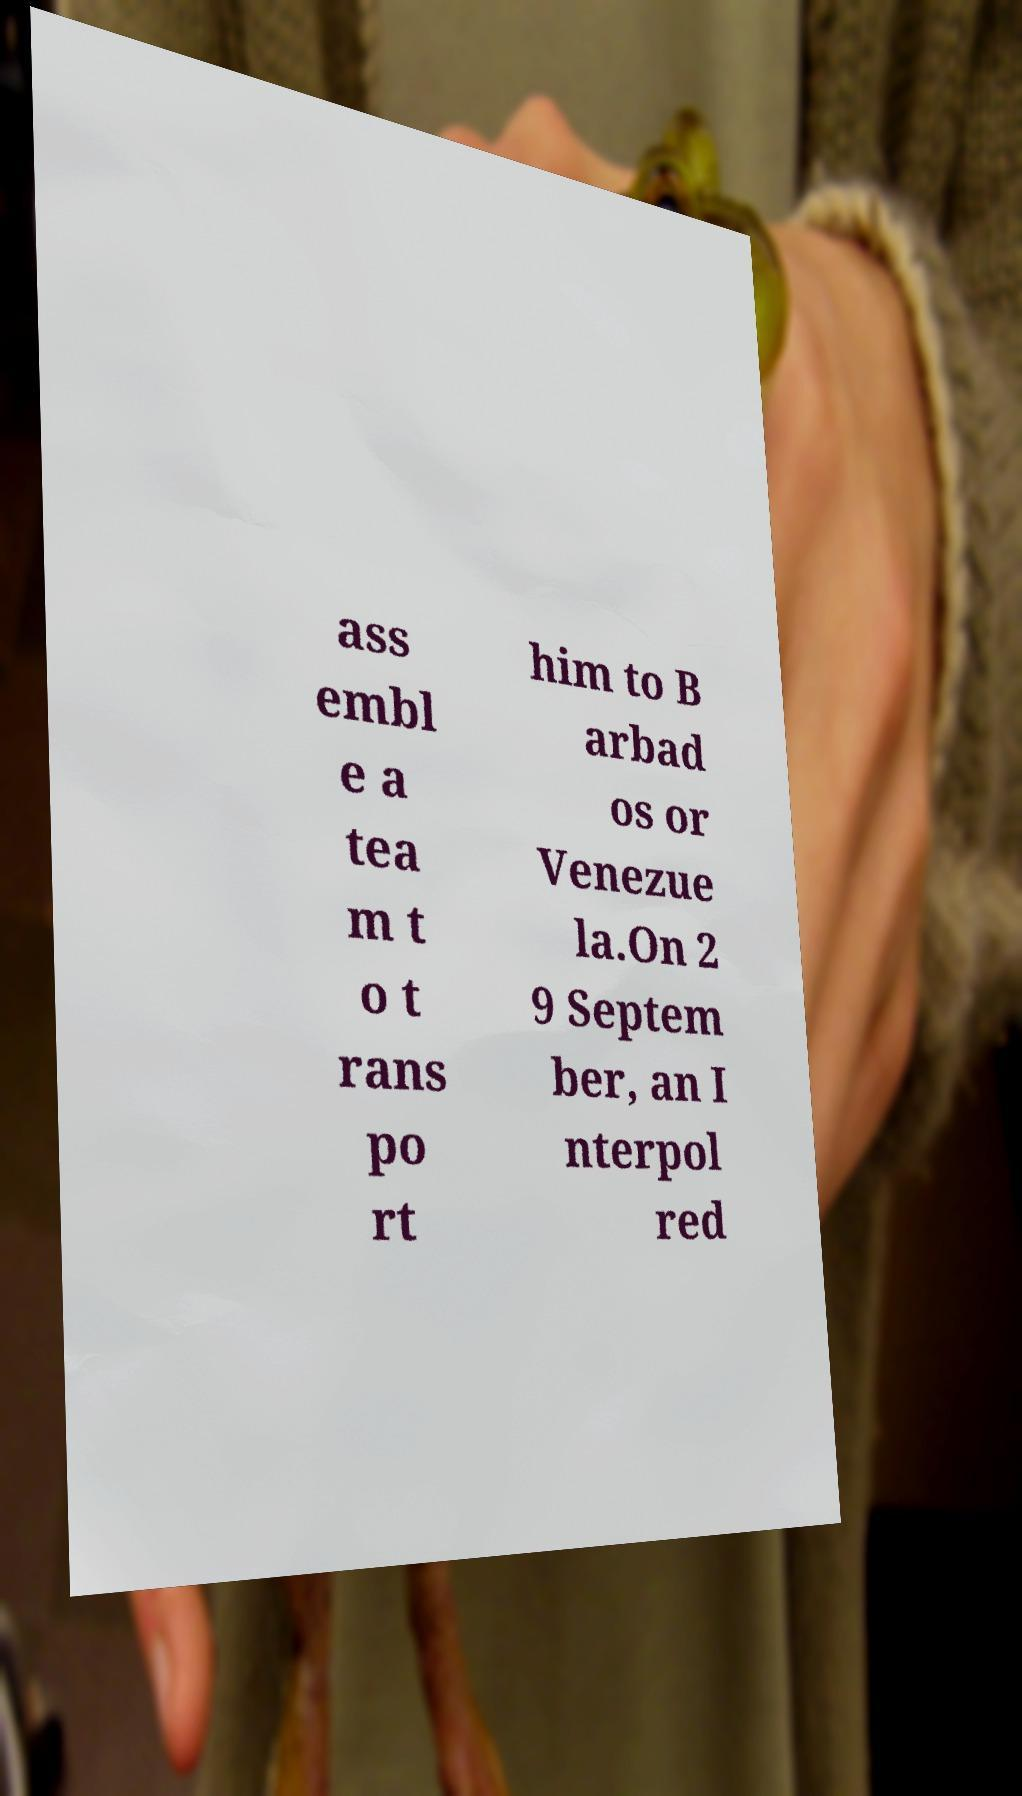Could you assist in decoding the text presented in this image and type it out clearly? ass embl e a tea m t o t rans po rt him to B arbad os or Venezue la.On 2 9 Septem ber, an I nterpol red 